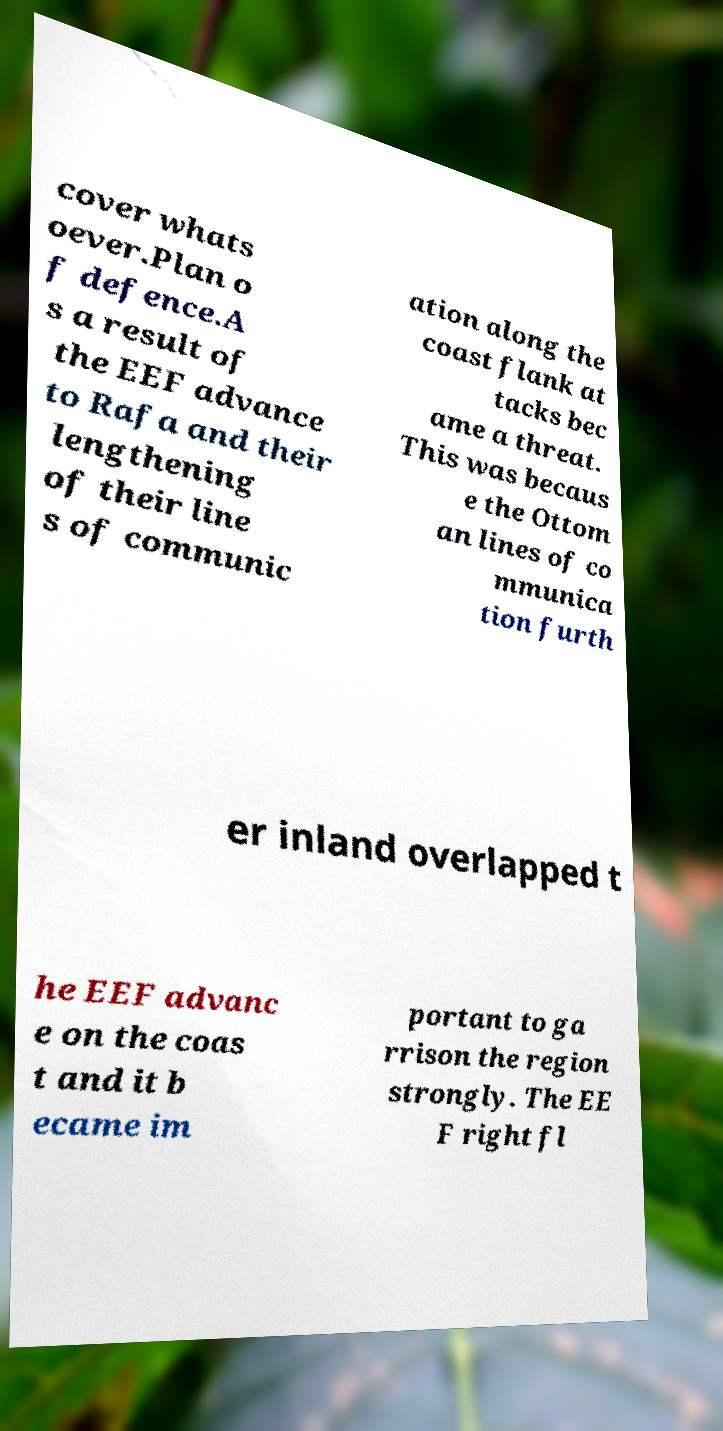I need the written content from this picture converted into text. Can you do that? cover whats oever.Plan o f defence.A s a result of the EEF advance to Rafa and their lengthening of their line s of communic ation along the coast flank at tacks bec ame a threat. This was becaus e the Ottom an lines of co mmunica tion furth er inland overlapped t he EEF advanc e on the coas t and it b ecame im portant to ga rrison the region strongly. The EE F right fl 